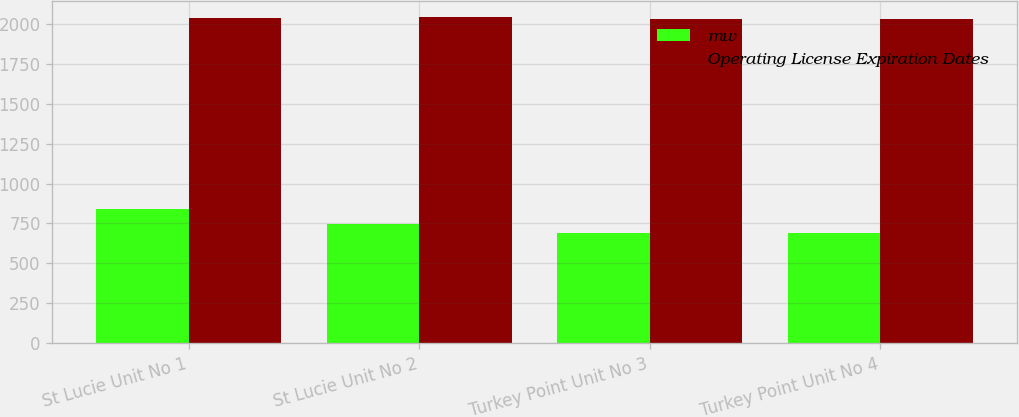<chart> <loc_0><loc_0><loc_500><loc_500><stacked_bar_chart><ecel><fcel>St Lucie Unit No 1<fcel>St Lucie Unit No 2<fcel>Turkey Point Unit No 3<fcel>Turkey Point Unit No 4<nl><fcel>mw<fcel>839<fcel>745<fcel>693<fcel>693<nl><fcel>Operating License Expiration Dates<fcel>2036<fcel>2043<fcel>2032<fcel>2033<nl></chart> 